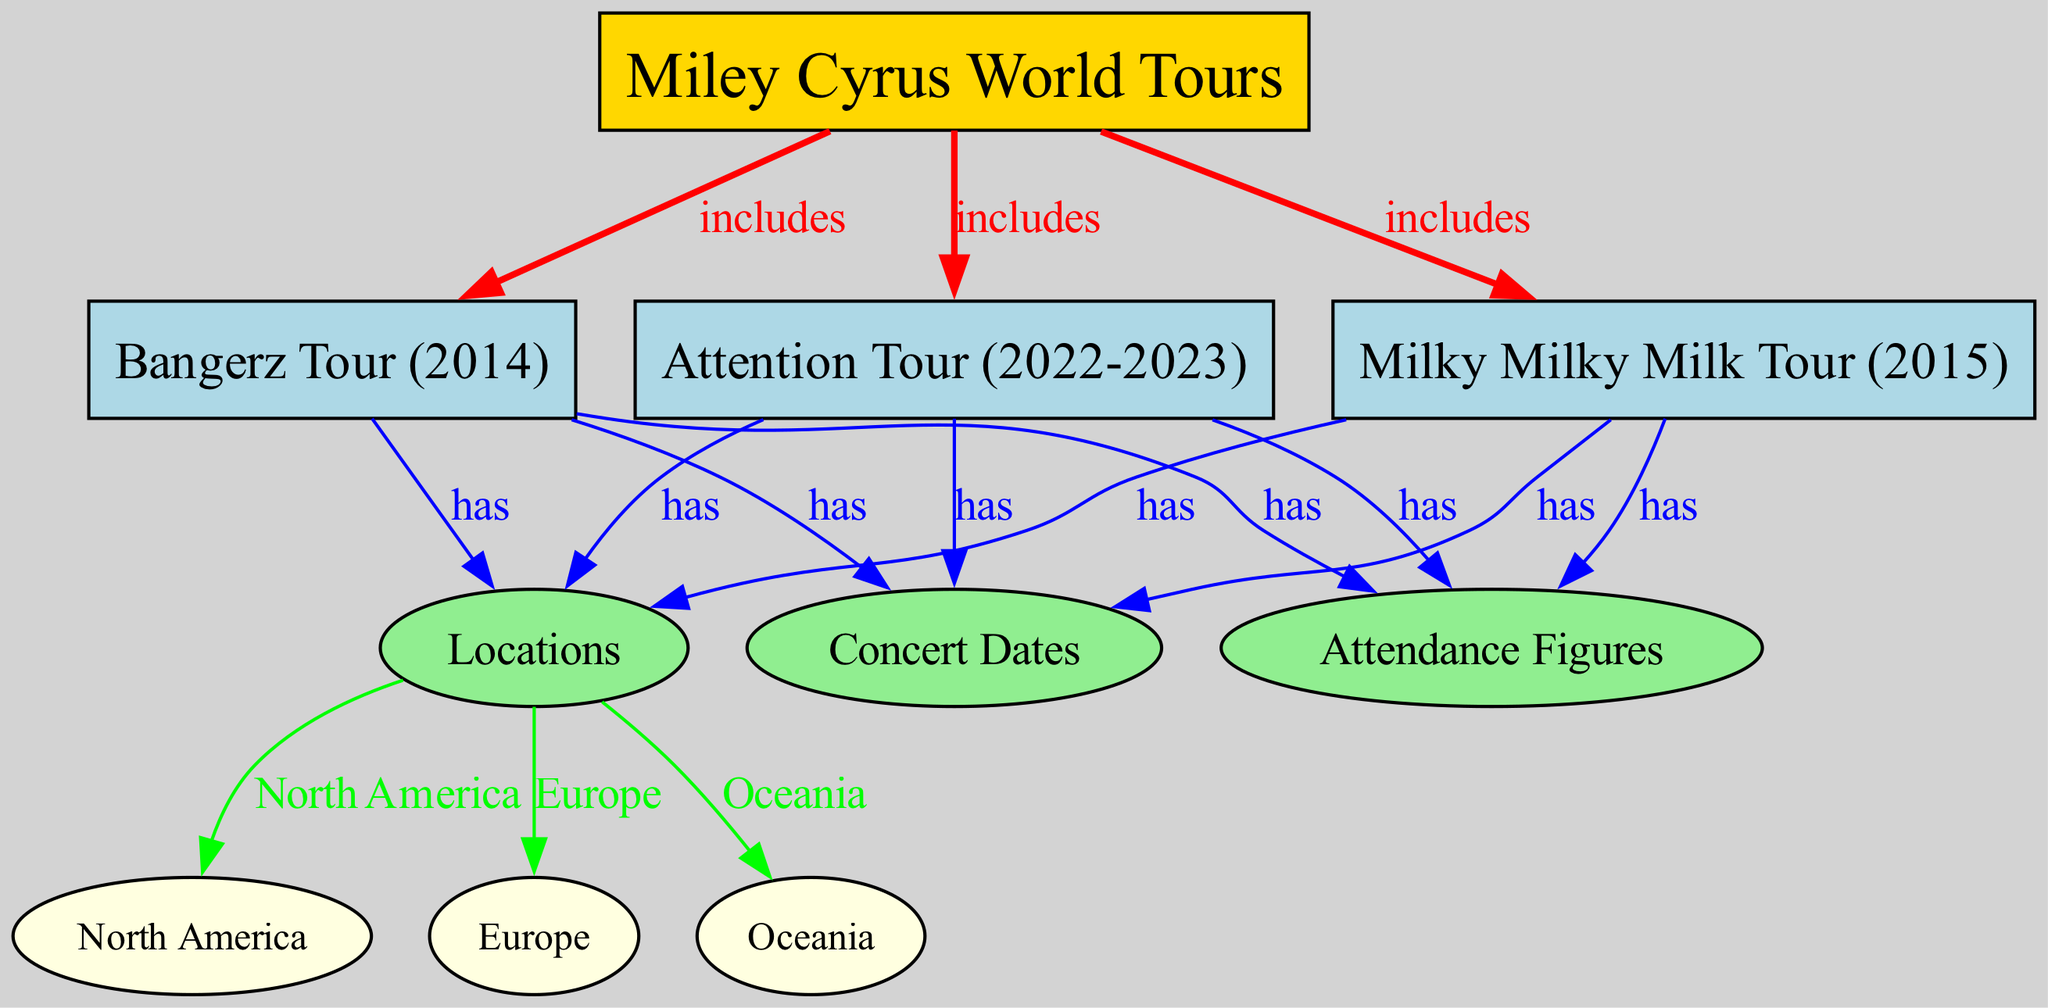What are the names of the tours included in Miley Cyrus's World Tours? The diagram shows three tours included in Miley Cyrus's World Tours: Bangerz Tour (2014), Milky Milky Milk Tour (2015), and Attention Tour (2022-2023).
Answer: Bangerz Tour (2014), Milky Milky Milk Tour (2015), Attention Tour (2022-2023) How many concert dates are associated with the Bangerz Tour? The Bangerz Tour has a node labeled "Concert Dates" that indicates it is connected to this category, revealing it has concert dates, but the specific number is not presented in the diagram.
Answer: Not specified In which locations did the Attention Tour take place? The diagram lists the locations linked to the Attention Tour as North America, Europe, and Oceania. By tracing the edges from the tour to the "Locations" node, we identify these three specific regions.
Answer: North America, Europe, Oceania What type of figure represents the 'Attendance Figures' in the diagram? The 'Attendance Figures' node is represented as an ellipse, which is typical for information categories rather than main events or subjects in this context. The shapes differentiate between tours (boxes) and data categories (ellipses).
Answer: Ellipse Which tour includes the most recent concert dates? The Attention Tour (2022-2023) is the most recent tour listed in the diagram, making it the one that includes the latest concert dates. It is the last element in this linear structure of tours.
Answer: Attention Tour (2022-2023) How many edges are connected to the Milky Milky Milk Tour? The Milky Milky Milk Tour has three edges connected to it, each leading to "Concert Dates," "Locations," and "Attendance Figures." Thus, you can count the individual edges emanating from this node to arrive at the answer.
Answer: 3 What color is used to represent the locations in the diagram? The locations in the diagram are represented in light green. This can be identified by observing the background color assigned to the "Locations" node and other related nodes like "Concert Dates" and "Attendance Figures," which follow the same color scheme.
Answer: Light green Which tour includes concert dates in Europe? The diagram establishes that both the Bangerz Tour and the Attention Tour include concert dates in Europe, as both are linked to the “Locations” node that connects to Europe. By checking the links from both tours to the location, we confirm this.
Answer: Bangerz Tour, Attention Tour 